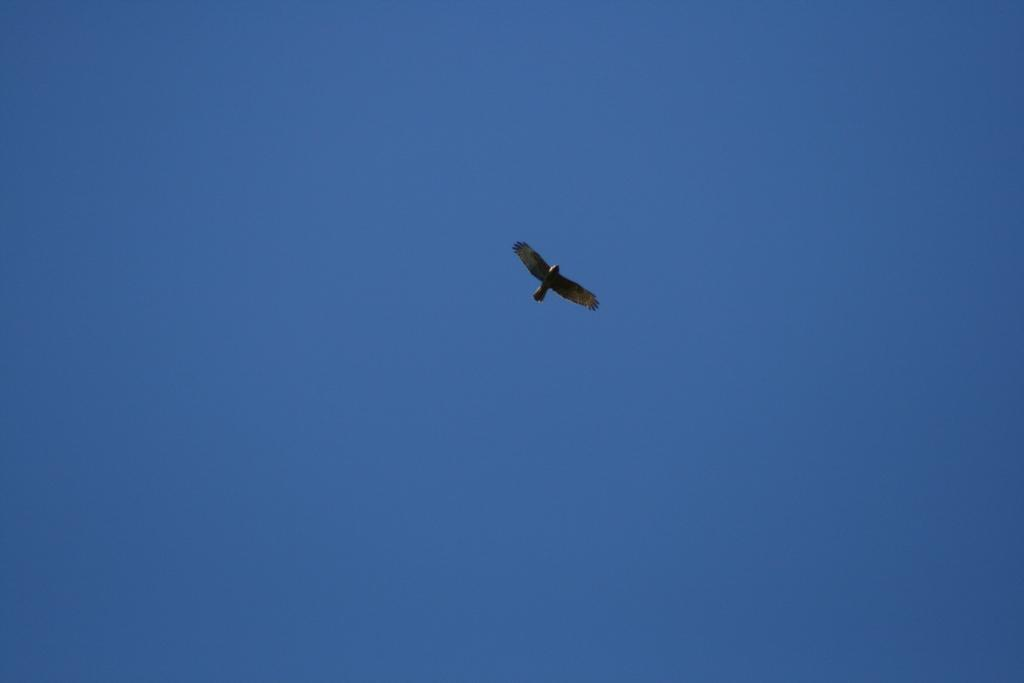Where was the picture taken? The picture was clicked outside. What can be seen in the sky in the image? There is a bird flying in the sky. What is visible in the background of the image? The sky is visible in the background of the image. How many slaves are visible in the image? There are no slaves present in the image. What type of sand can be seen on the ground in the image? There is no sand visible in the image; it was taken outside, but the ground is not specified. 